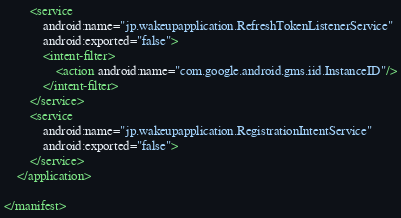<code> <loc_0><loc_0><loc_500><loc_500><_XML_>        <service
            android:name="jp.wakeupapplication.RefreshTokenListenerService"
            android:exported="false">
            <intent-filter>
                <action android:name="com.google.android.gms.iid.InstanceID"/>
            </intent-filter>
        </service>
        <service
            android:name="jp.wakeupapplication.RegistrationIntentService"
            android:exported="false">
        </service>
    </application>

</manifest></code> 